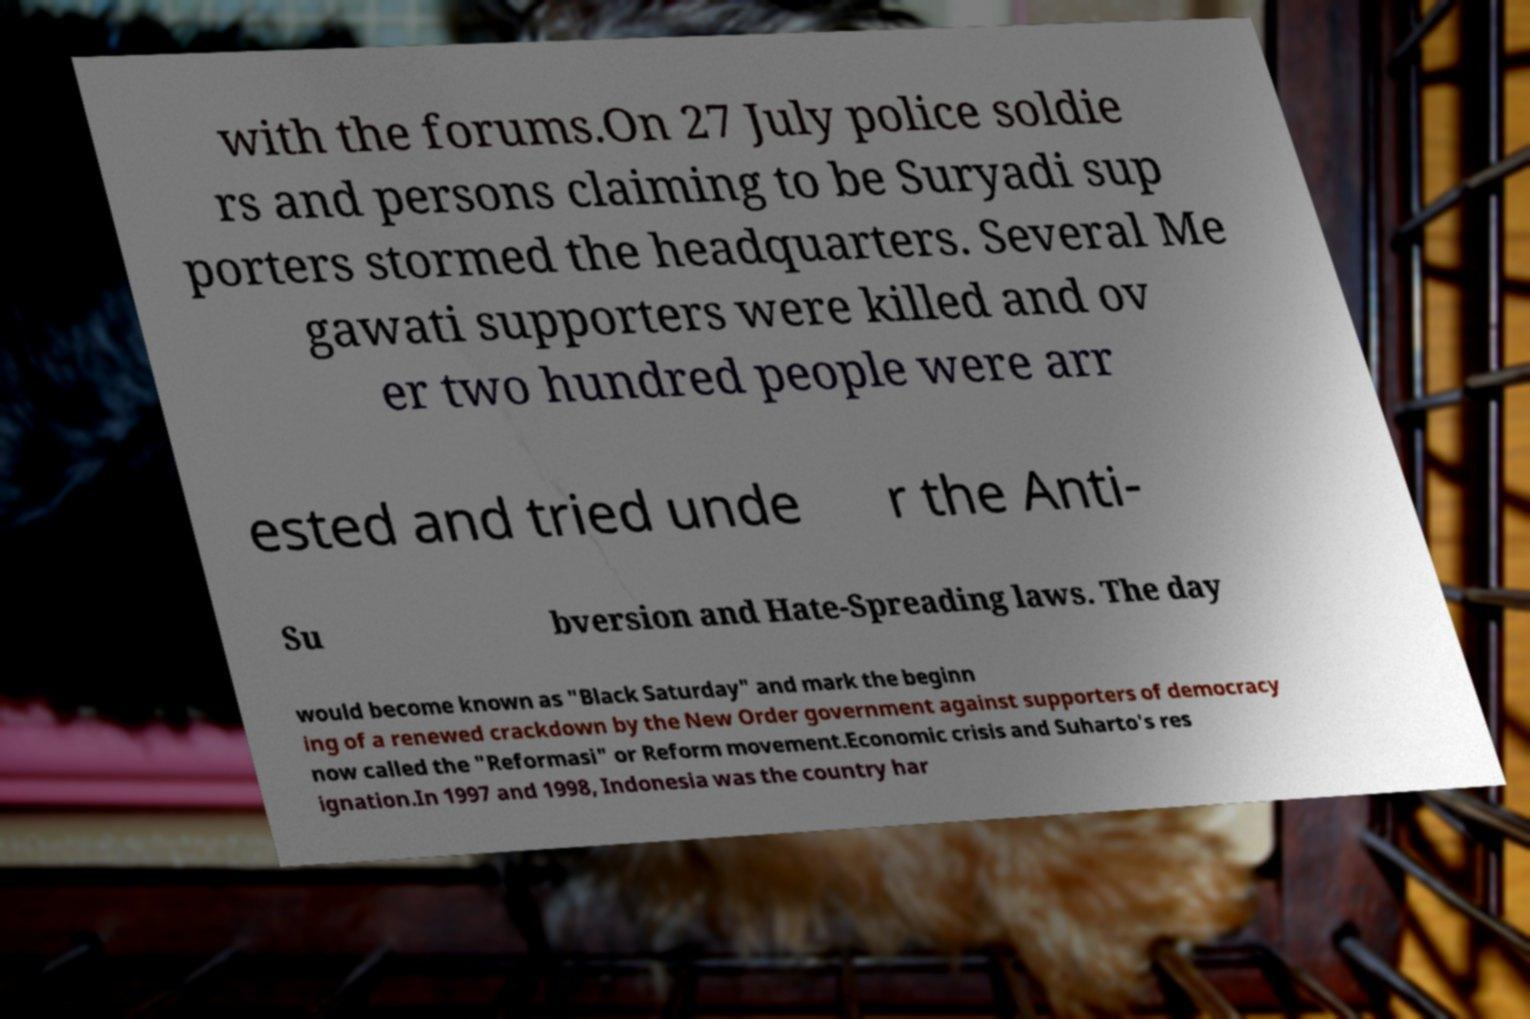Could you assist in decoding the text presented in this image and type it out clearly? with the forums.On 27 July police soldie rs and persons claiming to be Suryadi sup porters stormed the headquarters. Several Me gawati supporters were killed and ov er two hundred people were arr ested and tried unde r the Anti- Su bversion and Hate-Spreading laws. The day would become known as "Black Saturday" and mark the beginn ing of a renewed crackdown by the New Order government against supporters of democracy now called the "Reformasi" or Reform movement.Economic crisis and Suharto's res ignation.In 1997 and 1998, Indonesia was the country har 